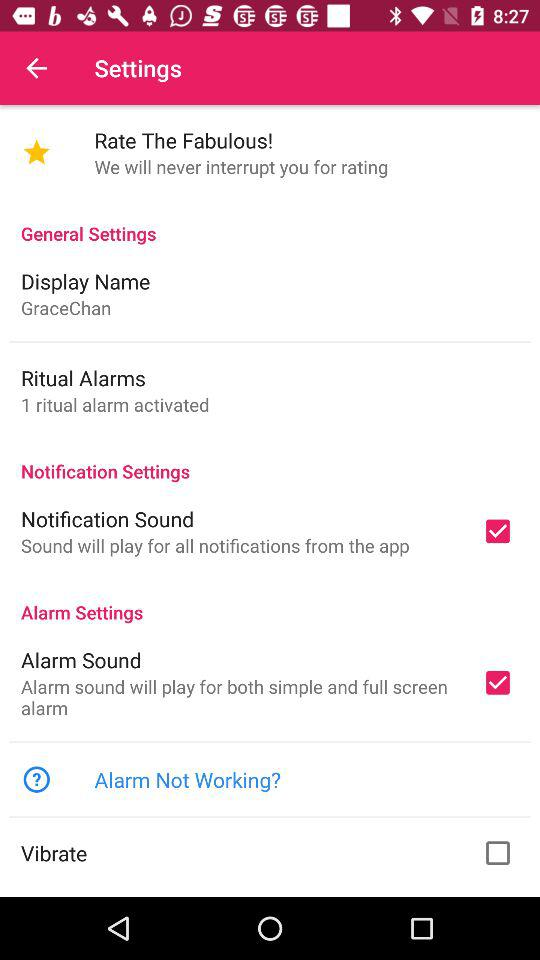What's the "Display Name"? The name of the display is Gracechan. 